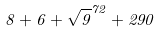<formula> <loc_0><loc_0><loc_500><loc_500>8 + 6 + \sqrt { 9 } ^ { 7 2 } + 2 9 0</formula> 